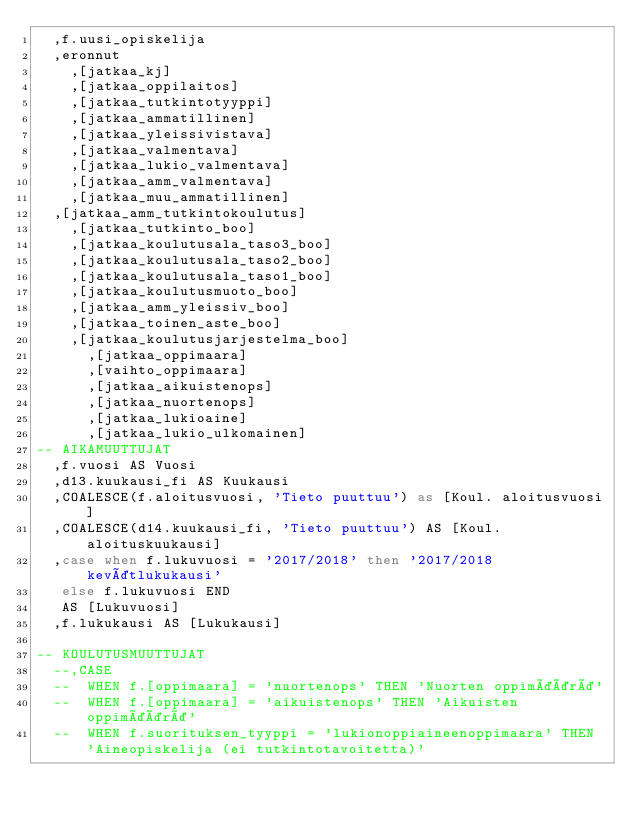Convert code to text. <code><loc_0><loc_0><loc_500><loc_500><_SQL_>	,f.uusi_opiskelija
	,eronnut
    ,[jatkaa_kj]
    ,[jatkaa_oppilaitos]
    ,[jatkaa_tutkintotyyppi]
    ,[jatkaa_ammatillinen]
    ,[jatkaa_yleissivistava]
    ,[jatkaa_valmentava]
    ,[jatkaa_lukio_valmentava]
    ,[jatkaa_amm_valmentava]
    ,[jatkaa_muu_ammatillinen]
	,[jatkaa_amm_tutkintokoulutus]
    ,[jatkaa_tutkinto_boo]
    ,[jatkaa_koulutusala_taso3_boo]
    ,[jatkaa_koulutusala_taso2_boo]
    ,[jatkaa_koulutusala_taso1_boo]
    ,[jatkaa_koulutusmuoto_boo]
    ,[jatkaa_amm_yleissiv_boo]
    ,[jatkaa_toinen_aste_boo]
    ,[jatkaa_koulutusjarjestelma_boo]
      ,[jatkaa_oppimaara]
      ,[vaihto_oppimaara]
      ,[jatkaa_aikuistenops]
      ,[jatkaa_nuortenops]
      ,[jatkaa_lukioaine]
      ,[jatkaa_lukio_ulkomainen]
-- AIKAMUUTTUJAT
	,f.vuosi AS Vuosi
	,d13.kuukausi_fi AS Kuukausi
	,COALESCE(f.aloitusvuosi, 'Tieto puuttuu') as [Koul. aloitusvuosi]
	,COALESCE(d14.kuukausi_fi, 'Tieto puuttuu') AS [Koul. aloituskuukausi]
	,case when f.lukuvuosi = '2017/2018' then '2017/2018 kevätlukukausi'
	 else f.lukuvuosi END 
	 AS [Lukuvuosi]
	,f.lukukausi AS [Lukukausi]

-- KOULUTUSMUUTTUJAT
	--,CASE
	--	WHEN f.[oppimaara] = 'nuortenops' THEN 'Nuorten oppimäärä'
	--	WHEN f.[oppimaara] = 'aikuistenops' THEN 'Aikuisten oppimäärä'
	--	WHEN f.suorituksen_tyyppi = 'lukionoppiaineenoppimaara' THEN 'Aineopiskelija (ei tutkintotavoitetta)'</code> 